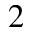Convert formula to latex. <formula><loc_0><loc_0><loc_500><loc_500>2</formula> 